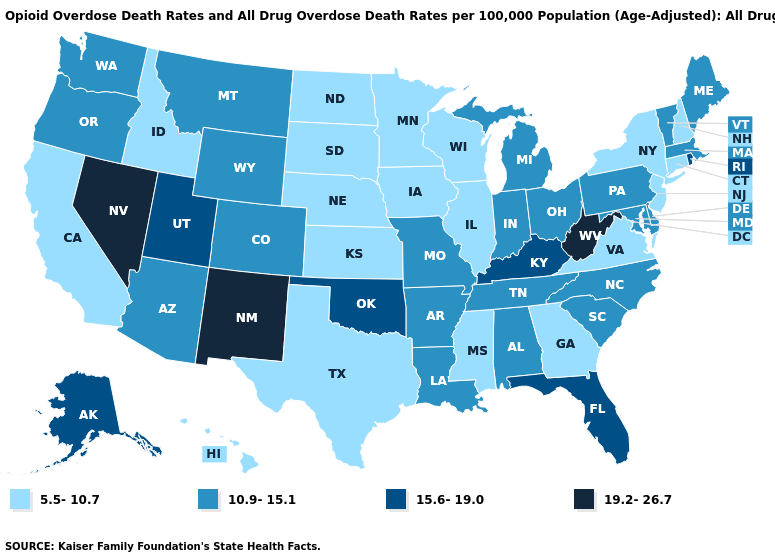What is the value of South Dakota?
Short answer required. 5.5-10.7. How many symbols are there in the legend?
Give a very brief answer. 4. What is the highest value in states that border California?
Give a very brief answer. 19.2-26.7. What is the value of Washington?
Quick response, please. 10.9-15.1. Name the states that have a value in the range 15.6-19.0?
Concise answer only. Alaska, Florida, Kentucky, Oklahoma, Rhode Island, Utah. Does Minnesota have the lowest value in the USA?
Quick response, please. Yes. What is the value of Arkansas?
Answer briefly. 10.9-15.1. Which states hav the highest value in the West?
Concise answer only. Nevada, New Mexico. Which states have the lowest value in the South?
Be succinct. Georgia, Mississippi, Texas, Virginia. Does New Mexico have the highest value in the USA?
Answer briefly. Yes. Among the states that border Arkansas , which have the lowest value?
Concise answer only. Mississippi, Texas. What is the value of Massachusetts?
Short answer required. 10.9-15.1. Among the states that border Washington , which have the lowest value?
Quick response, please. Idaho. What is the highest value in states that border Massachusetts?
Answer briefly. 15.6-19.0. What is the value of Virginia?
Keep it brief. 5.5-10.7. 